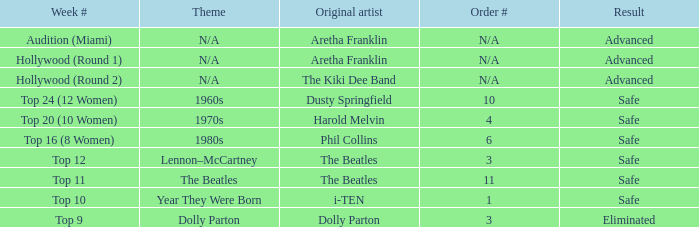Can you tell me the artist behind the song that holds the 9th position in this week's chart? Dolly Parton. 